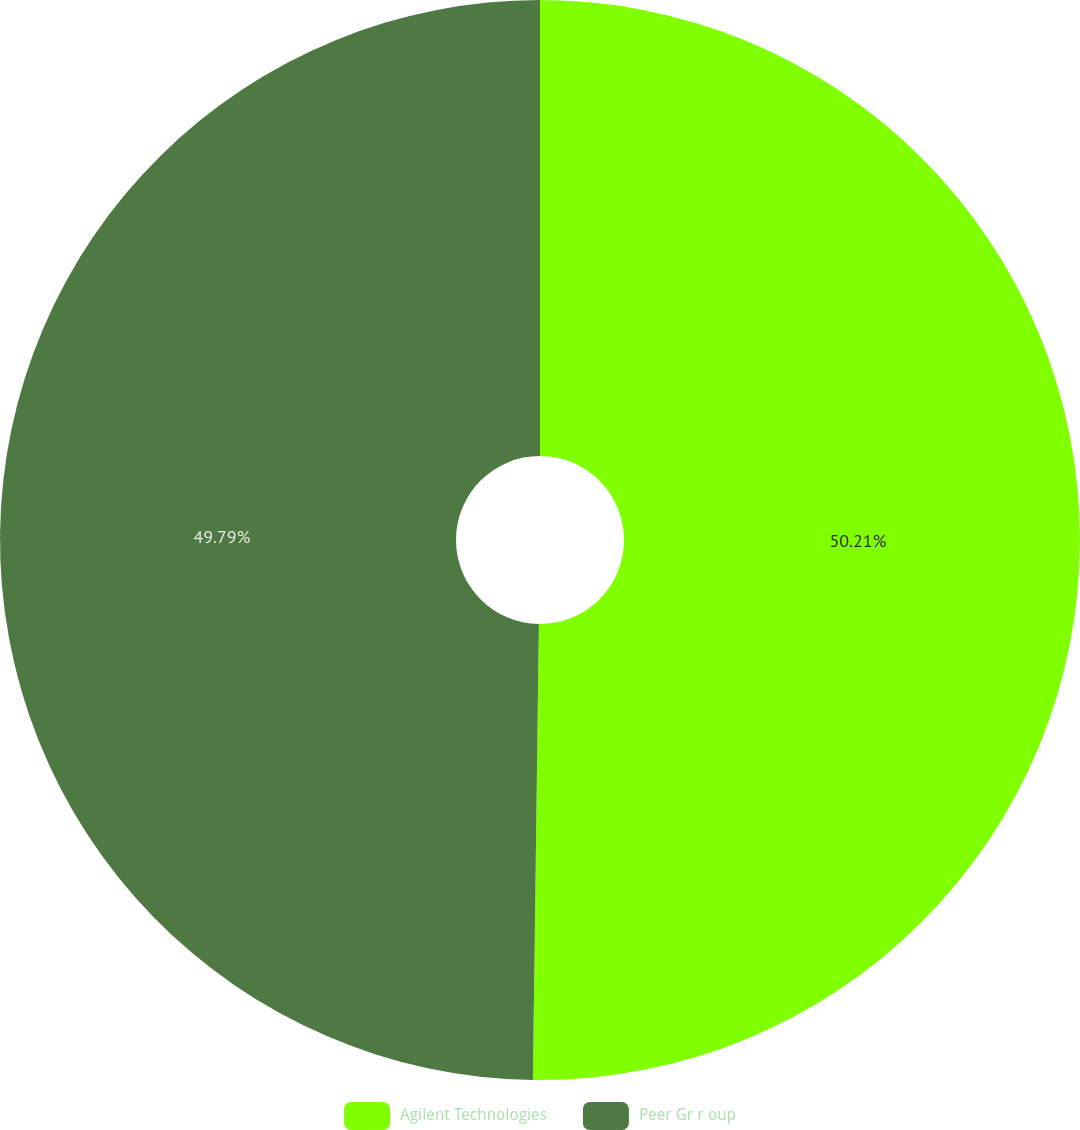<chart> <loc_0><loc_0><loc_500><loc_500><pie_chart><fcel>Agilent Technologies<fcel>Peer Gr r oup<nl><fcel>50.21%<fcel>49.79%<nl></chart> 